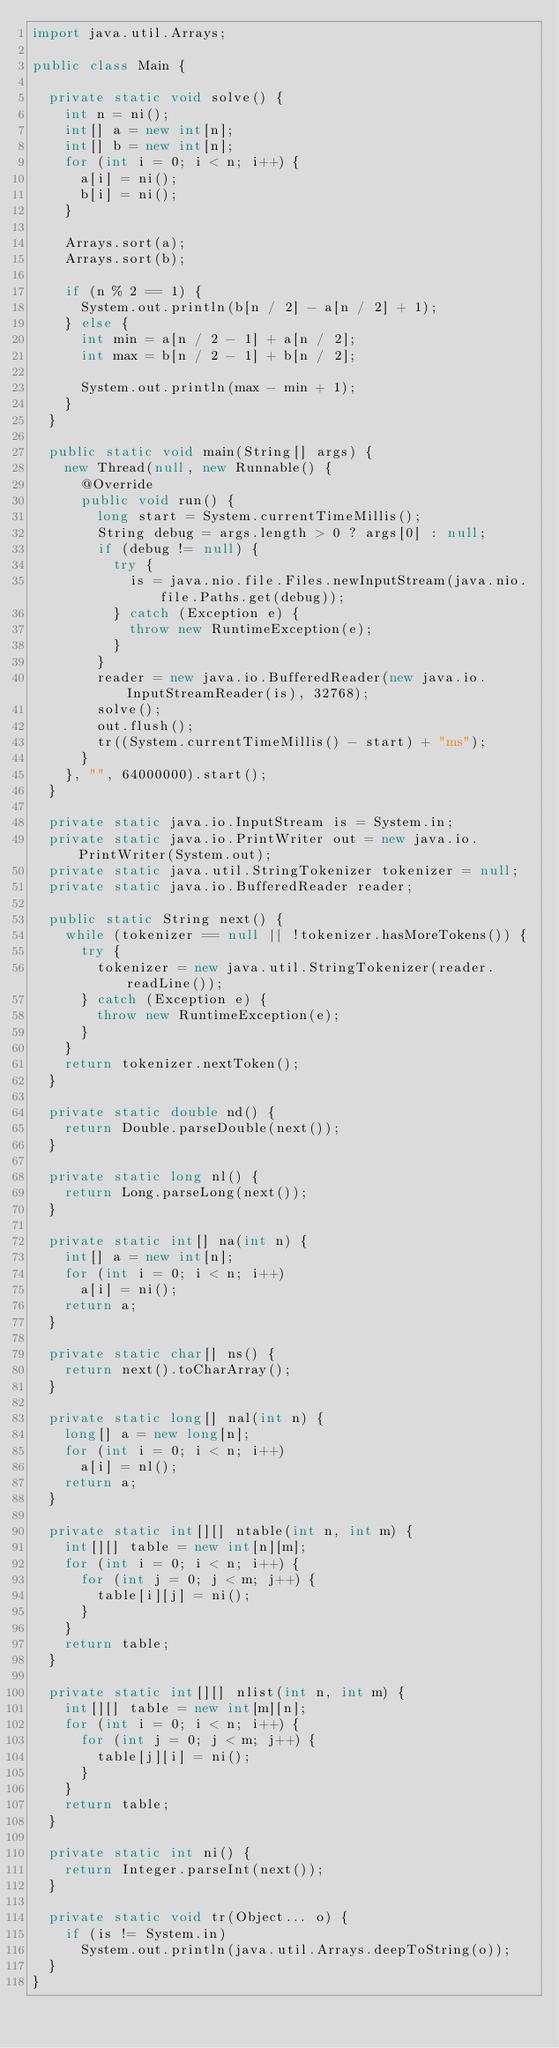<code> <loc_0><loc_0><loc_500><loc_500><_Java_>import java.util.Arrays;

public class Main {

  private static void solve() {
    int n = ni();
    int[] a = new int[n];
    int[] b = new int[n];
    for (int i = 0; i < n; i++) {
      a[i] = ni();
      b[i] = ni();
    }

    Arrays.sort(a);
    Arrays.sort(b);

    if (n % 2 == 1) {
      System.out.println(b[n / 2] - a[n / 2] + 1);
    } else {
      int min = a[n / 2 - 1] + a[n / 2];
      int max = b[n / 2 - 1] + b[n / 2];

      System.out.println(max - min + 1);
    }
  }

  public static void main(String[] args) {
    new Thread(null, new Runnable() {
      @Override
      public void run() {
        long start = System.currentTimeMillis();
        String debug = args.length > 0 ? args[0] : null;
        if (debug != null) {
          try {
            is = java.nio.file.Files.newInputStream(java.nio.file.Paths.get(debug));
          } catch (Exception e) {
            throw new RuntimeException(e);
          }
        }
        reader = new java.io.BufferedReader(new java.io.InputStreamReader(is), 32768);
        solve();
        out.flush();
        tr((System.currentTimeMillis() - start) + "ms");
      }
    }, "", 64000000).start();
  }

  private static java.io.InputStream is = System.in;
  private static java.io.PrintWriter out = new java.io.PrintWriter(System.out);
  private static java.util.StringTokenizer tokenizer = null;
  private static java.io.BufferedReader reader;

  public static String next() {
    while (tokenizer == null || !tokenizer.hasMoreTokens()) {
      try {
        tokenizer = new java.util.StringTokenizer(reader.readLine());
      } catch (Exception e) {
        throw new RuntimeException(e);
      }
    }
    return tokenizer.nextToken();
  }

  private static double nd() {
    return Double.parseDouble(next());
  }

  private static long nl() {
    return Long.parseLong(next());
  }

  private static int[] na(int n) {
    int[] a = new int[n];
    for (int i = 0; i < n; i++)
      a[i] = ni();
    return a;
  }

  private static char[] ns() {
    return next().toCharArray();
  }

  private static long[] nal(int n) {
    long[] a = new long[n];
    for (int i = 0; i < n; i++)
      a[i] = nl();
    return a;
  }

  private static int[][] ntable(int n, int m) {
    int[][] table = new int[n][m];
    for (int i = 0; i < n; i++) {
      for (int j = 0; j < m; j++) {
        table[i][j] = ni();
      }
    }
    return table;
  }

  private static int[][] nlist(int n, int m) {
    int[][] table = new int[m][n];
    for (int i = 0; i < n; i++) {
      for (int j = 0; j < m; j++) {
        table[j][i] = ni();
      }
    }
    return table;
  }

  private static int ni() {
    return Integer.parseInt(next());
  }

  private static void tr(Object... o) {
    if (is != System.in)
      System.out.println(java.util.Arrays.deepToString(o));
  }
}
</code> 